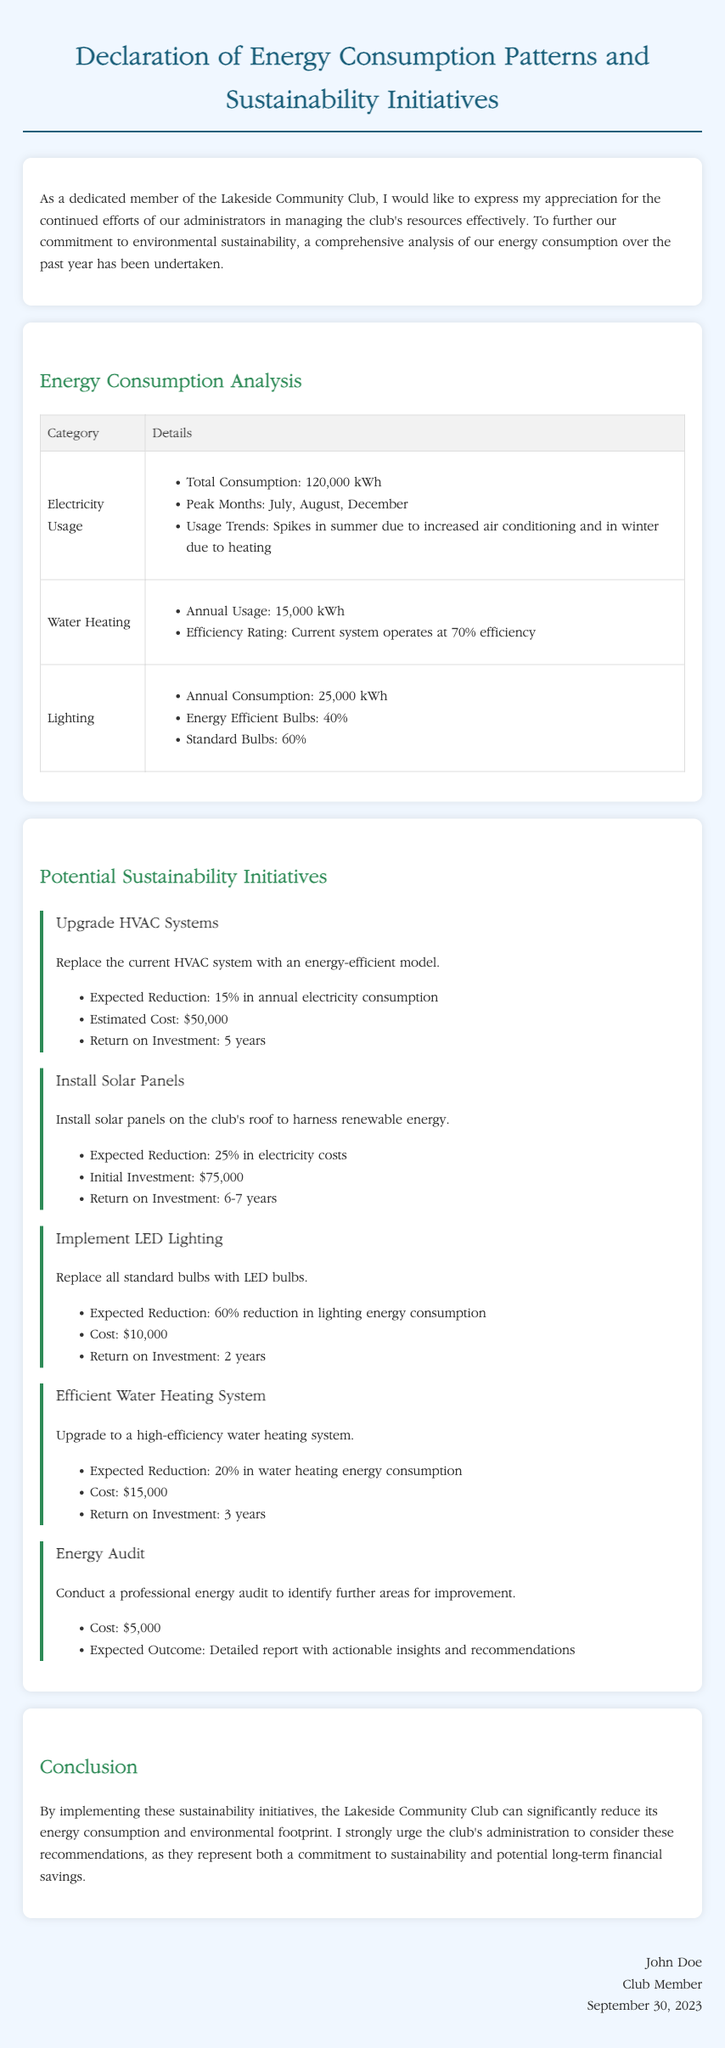What is the total electricity consumption? The total electricity consumption is specified in the analysis section and amounts to 120,000 kWh.
Answer: 120,000 kWh What is the efficiency rating of the current water heating system? The efficiency rating for the current water heating system is mentioned in the details as 70%.
Answer: 70% Which months have peak electricity usage? The peak months for electricity usage are listed in the document as July, August, and December.
Answer: July, August, December What is the expected reduction in electricity consumption after upgrading HVAC systems? The expected reduction for the HVAC system upgrade is indicated in the potential sustainability initiatives as 15%.
Answer: 15% How much does the energy audit cost? In the potential sustainability initiatives, the cost for conducting the energy audit is specified as $5,000.
Answer: $5,000 What is the return on investment for implementing LED lighting? The return on investment for implementing LED lighting is detailed in the initiatives section and is 2 years.
Answer: 2 years What is the estimated cost to install solar panels? The initiative for installing solar panels mentions an initial investment of $75,000.
Answer: $75,000 How much will replacing standard bulbs with LED bulbs reduce lighting energy consumption? The reduction in lighting energy consumption when replacing standard bulbs with LED bulbs is stated as 60%.
Answer: 60% What is the conclusion regarding the sustainability initiatives? The conclusion emphasizes significantly reducing energy consumption and environmental footprint through the proposed initiatives.
Answer: Reduce energy consumption and footprint 